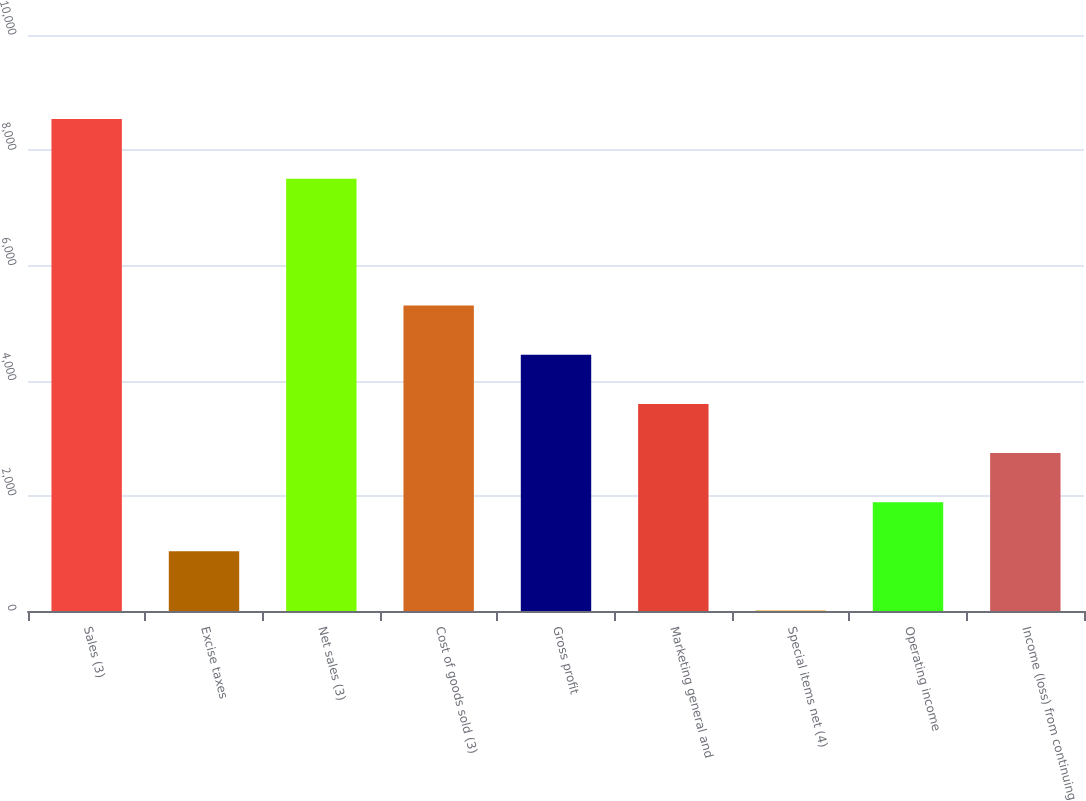Convert chart. <chart><loc_0><loc_0><loc_500><loc_500><bar_chart><fcel>Sales (3)<fcel>Excise taxes<fcel>Net sales (3)<fcel>Cost of goods sold (3)<fcel>Gross profit<fcel>Marketing general and<fcel>Special items net (4)<fcel>Operating income<fcel>Income (loss) from continuing<nl><fcel>8541.7<fcel>1036<fcel>7505.7<fcel>5301.9<fcel>4448.72<fcel>3595.54<fcel>9.9<fcel>1889.18<fcel>2742.36<nl></chart> 